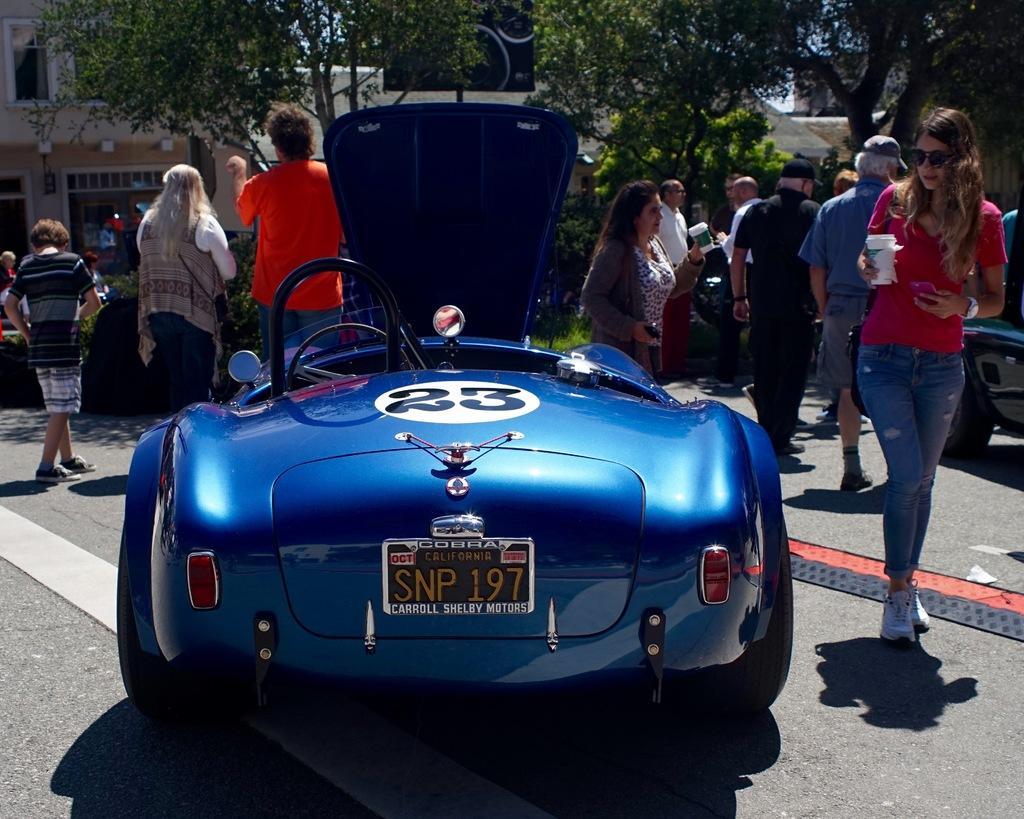How would you summarize this image in a sentence or two? In this image, there are a few people, vehicles, buildings, trees, plants. We can also see the ground. 